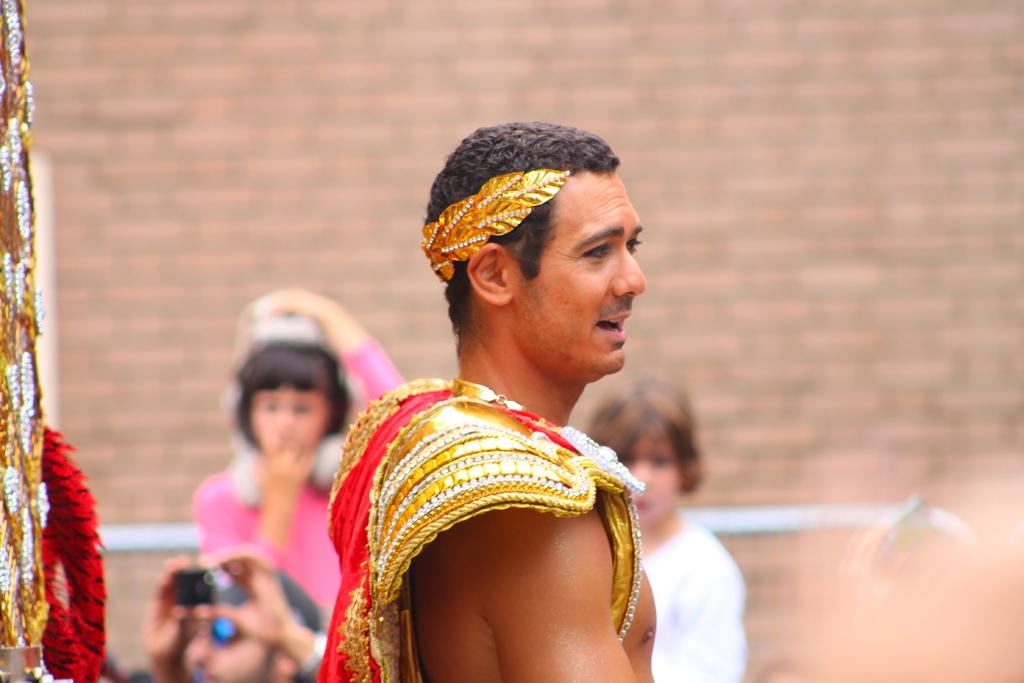What is the main subject of subject of the picture? The main subject of the picture is a person. Where is the person located in the image? The person is standing in the middle of the image. What is the person wearing? The person is wearing a fancy dress. What type of linen can be seen hanging from the church in the image? There is no church or linen present in the image; it features a person standing in the middle of the image wearing a fancy dress. 